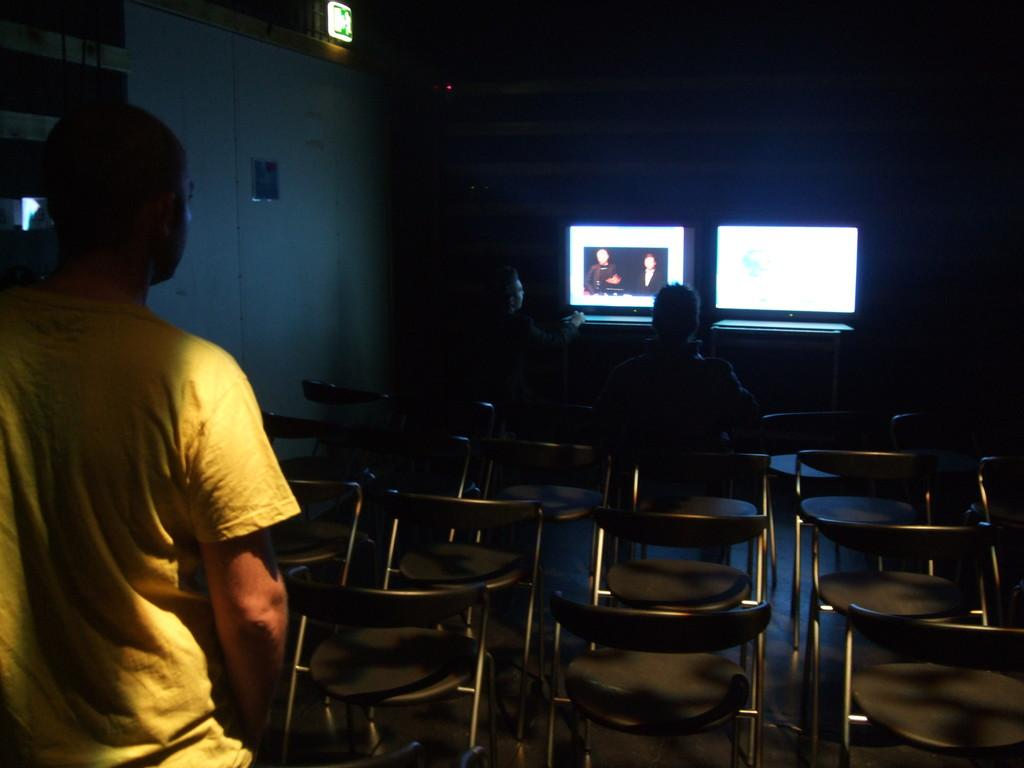What is the man in the image doing? The man is standing in the image. What is the man wearing? The man is wearing a yellow t-shirt. What objects are present in the image besides the man? There are chairs in the image. What are the two persons in the image doing? Two persons are sitting and watching a screen. What type of wine is being served in the image? There is no wine present in the image. What form does the rose take in the image? There is no rose present in the image. 